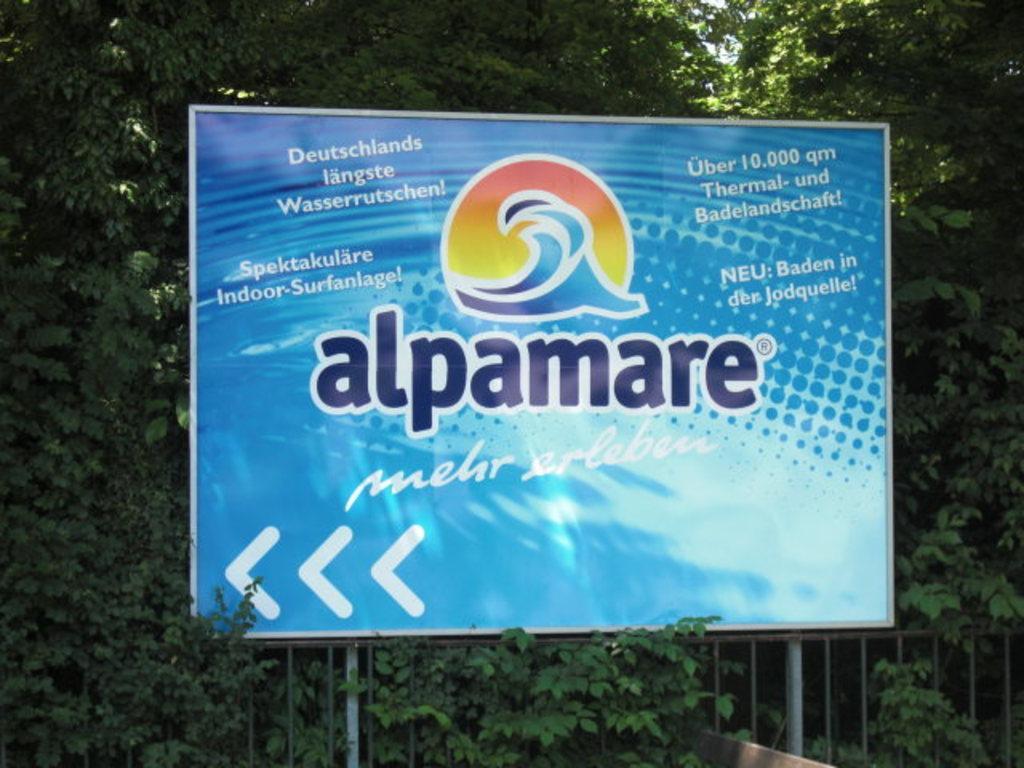Describe this image in one or two sentences. In this image I can see a huge banner which is blue in color, the metal railing and few trees which are green in color. In the background I can see the sky. 